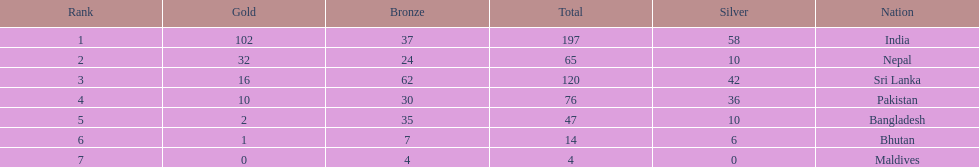What was the number of silver medals won by pakistan? 36. 